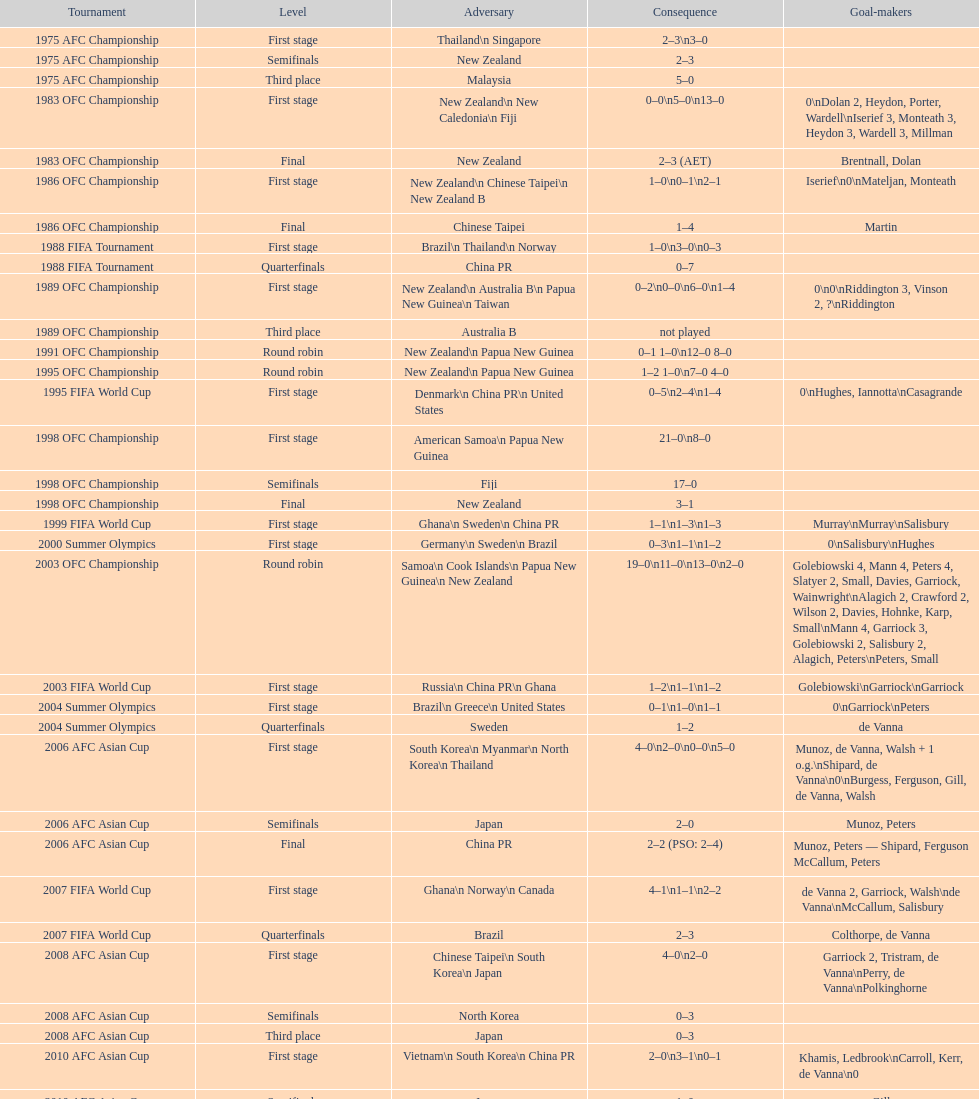What is the difference in the number of goals scored in the 1999 fifa world cup and the 2000 summer olympics? 2. 